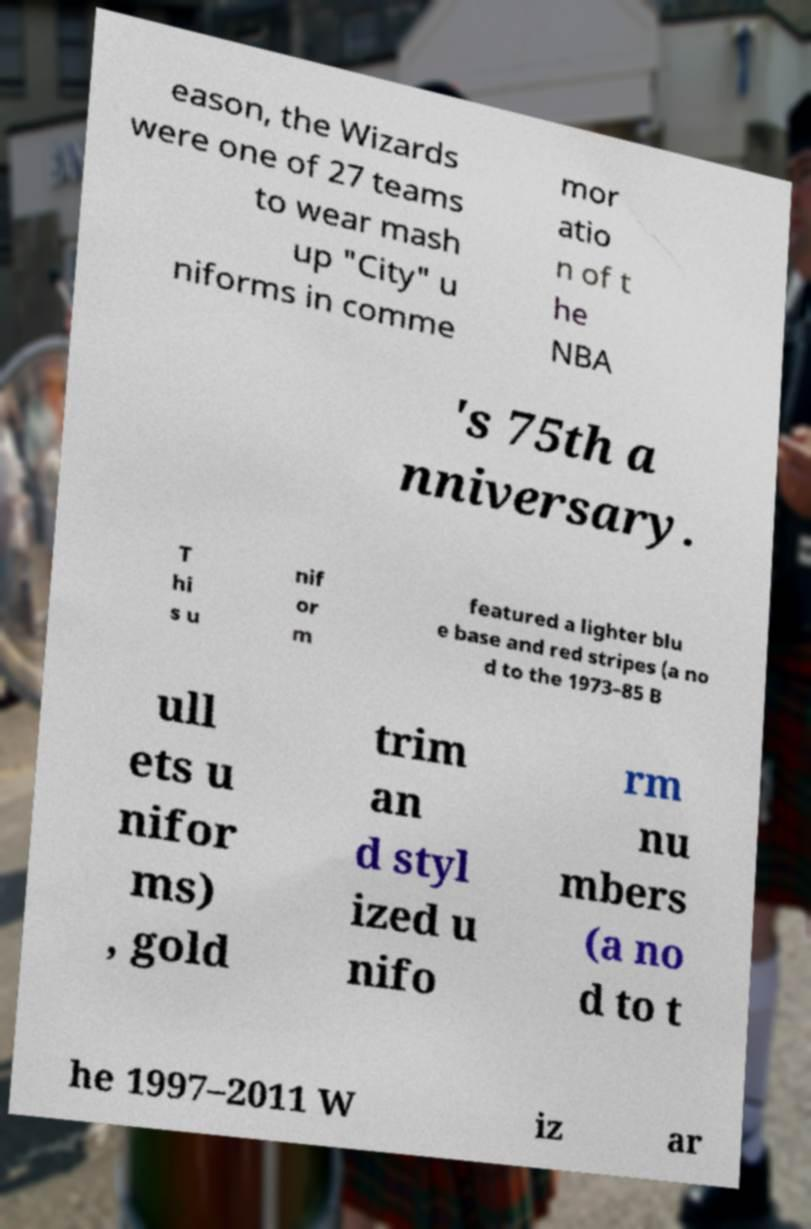Please identify and transcribe the text found in this image. eason, the Wizards were one of 27 teams to wear mash up "City" u niforms in comme mor atio n of t he NBA 's 75th a nniversary. T hi s u nif or m featured a lighter blu e base and red stripes (a no d to the 1973–85 B ull ets u nifor ms) , gold trim an d styl ized u nifo rm nu mbers (a no d to t he 1997–2011 W iz ar 